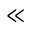Convert formula to latex. <formula><loc_0><loc_0><loc_500><loc_500>\ll</formula> 